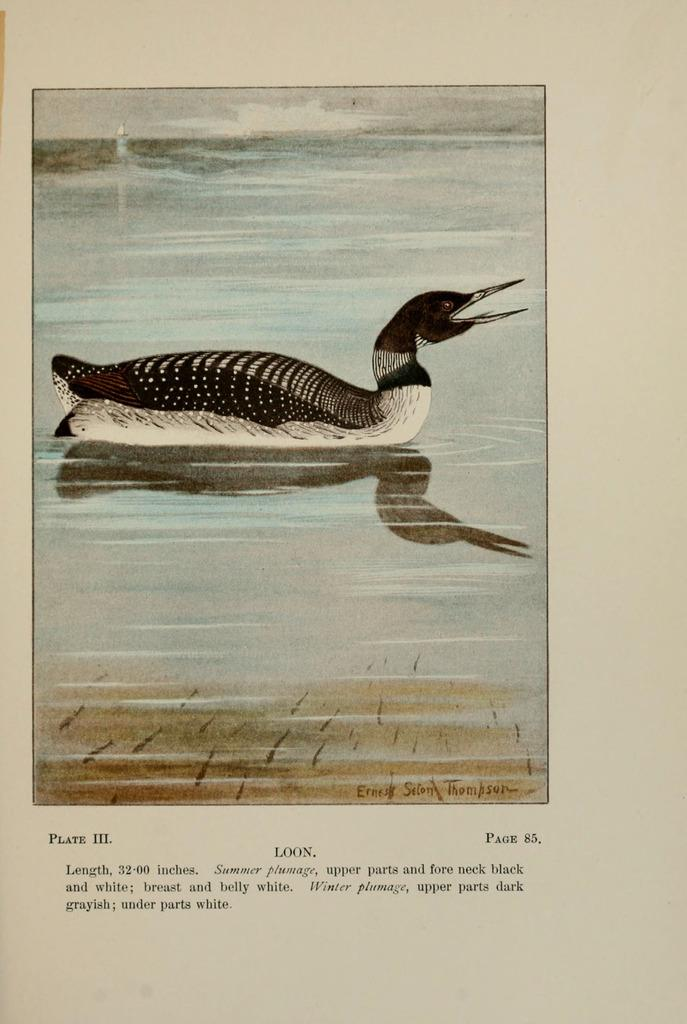What is the main subject of the page in the image? The page contains a picture of a duck. What else can be found on the page besides the picture? There is text on the page. Can you tell me how many firemen are present in the image? There are no firemen present in the image; it only contains a page with a picture of a duck and text. 